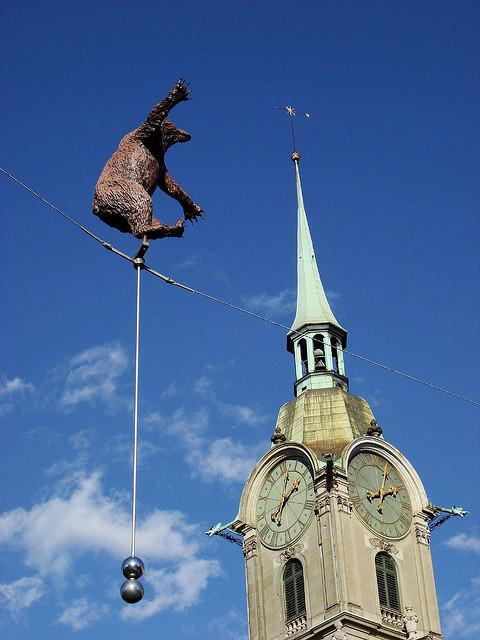What time is it?
Give a very brief answer. 2:05. What is the bear doing?
Quick response, please. Balancing. Why is the steeple green?
Answer briefly. To match clock. 